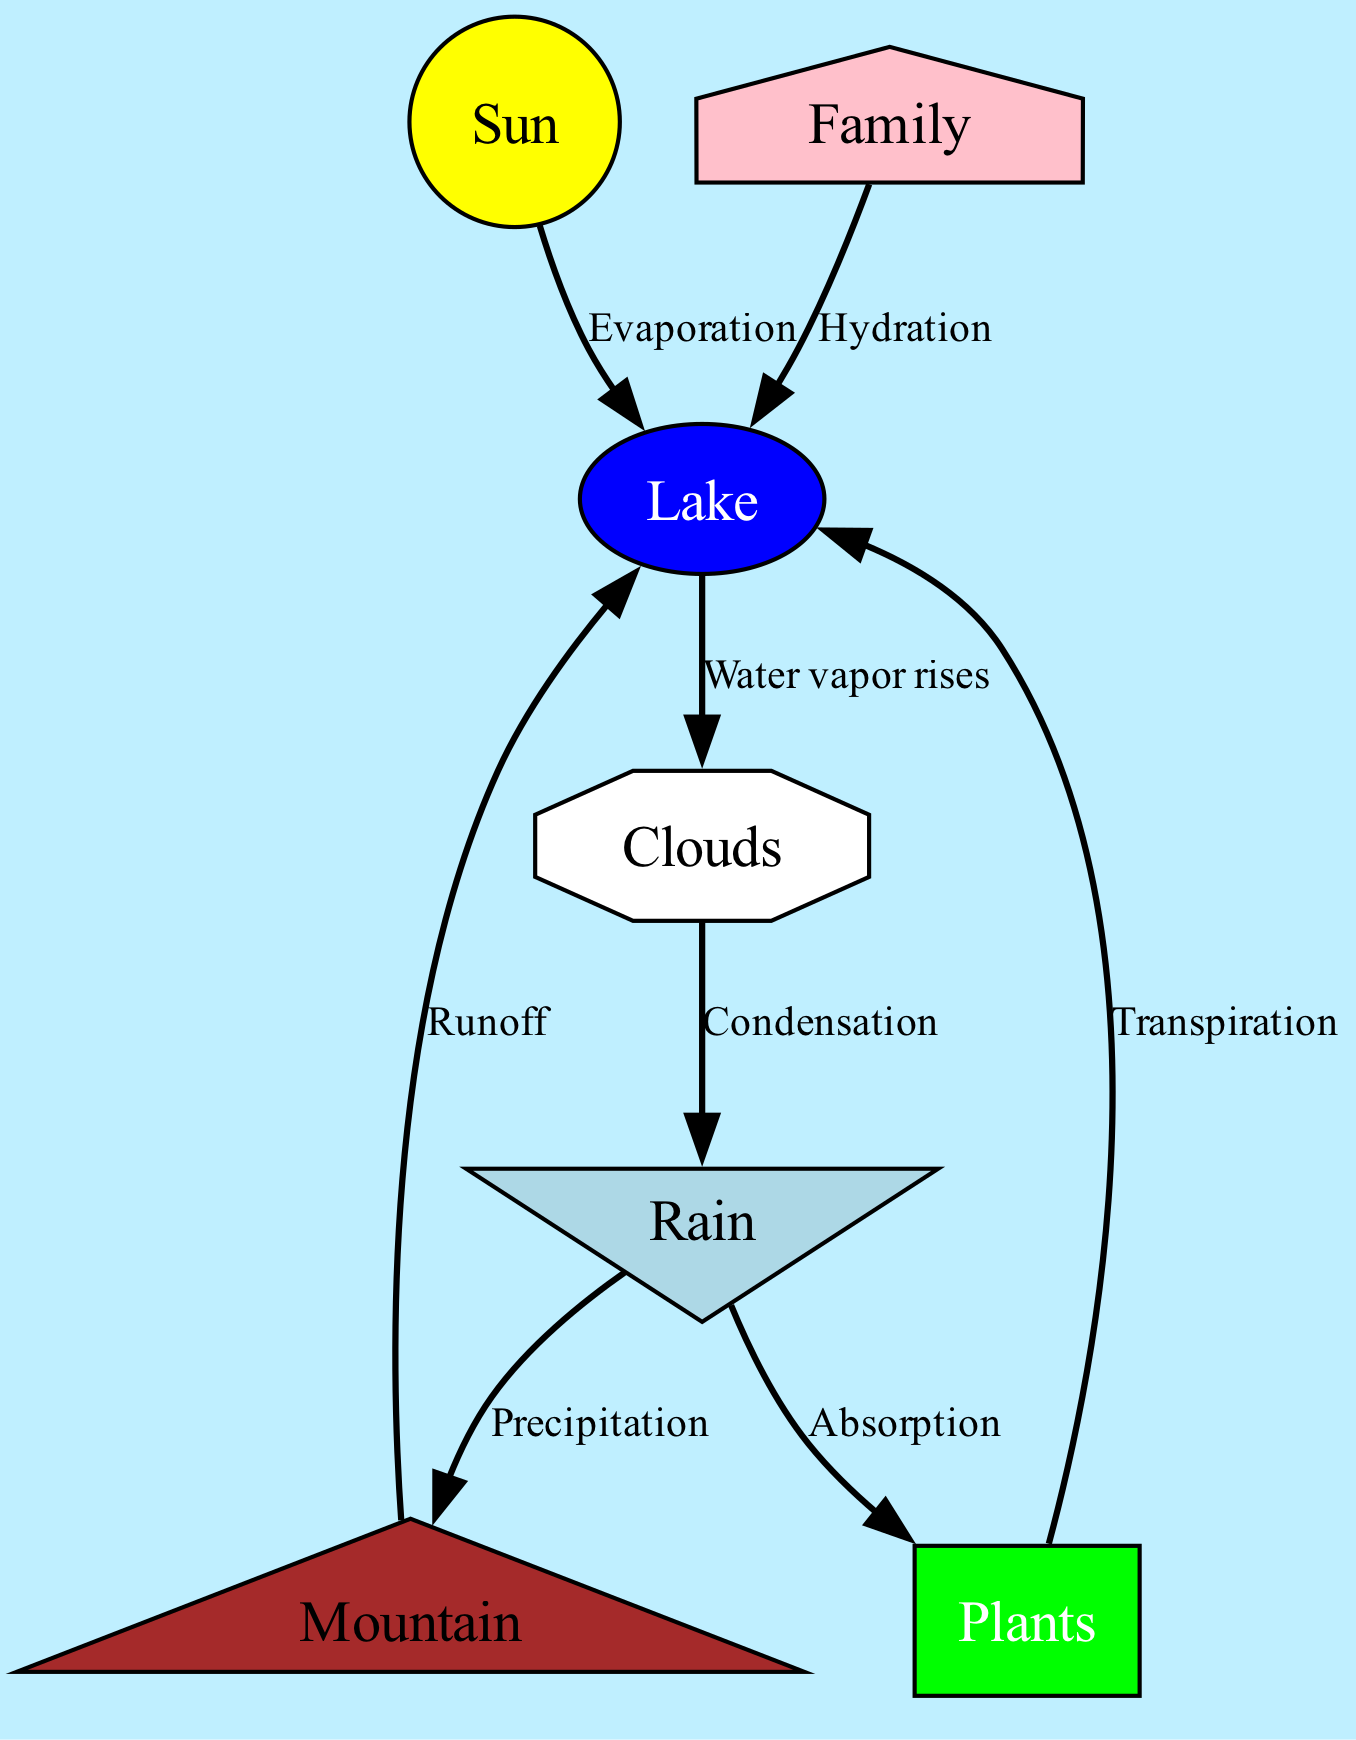What is the first step in the water cycle? The diagram indicates that the first step is "Evaporation" from the "Lake" as indicated by the edge connecting the "Sun" to the "Lake" labeled "Evaporation".
Answer: Evaporation How many main nodes are in the diagram? To determine the number of unique entities involved in the water cycle, we count the nodes listed: Sun, Clouds, Rain, Mountain, Lake, Plants, and Family. This totals seven distinct nodes.
Answer: 7 What process follows condensation? From the diagram, the process that follows "Condensation" is indicated by the edge connecting "Clouds" to "Rain", showing the transition occurs after condensation.
Answer: Rain What happens to rainwater that reaches the mountain? The edge labeled "Precipitation" indicates that rainwater flows to "Mountain" when it falls from the clouds, leading to the next step of water moving through the ecosystem.
Answer: Mountain What do plants do with rainwater? According to the diagram, "Plants" absorb water from "Rain", as shown by the edge connecting "Rain" to "Plants" labeled "Absorption".
Answer: Absorption How does water get from the lake to the clouds? The diagram shows that water vapor rises from the "Lake" to the "Clouds", which is represented by the directed edge connecting these two nodes, labeled "Water vapor rises".
Answer: Water vapor rises What color is the lake represented in the diagram? The color associated with the "Lake" node in the diagram is "blue", as indicated by the properties set for that node.
Answer: Blue What is the relationship between Family and Lake? The diagram shows that the "Family" node is connected to the "Lake" through the edge labeled "Hydration", implying that the family relies on the lake for drinking water.
Answer: Hydration How do plants return water to the lake? The diagram indicates that "Plants" return water to the "Lake" through a process called "Transpiration", as shown by the edge connecting these nodes.
Answer: Transpiration 